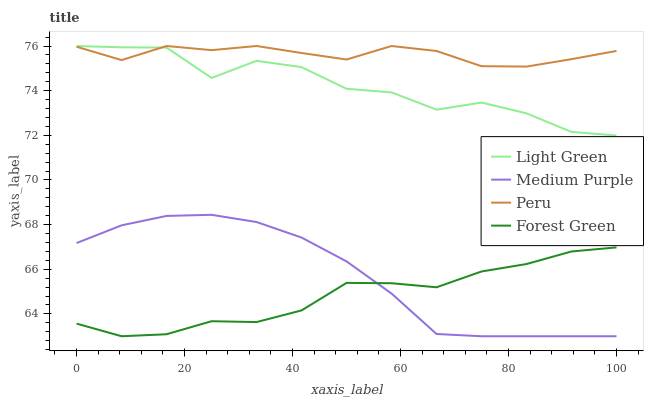Does Forest Green have the minimum area under the curve?
Answer yes or no. Yes. Does Peru have the maximum area under the curve?
Answer yes or no. Yes. Does Peru have the minimum area under the curve?
Answer yes or no. No. Does Forest Green have the maximum area under the curve?
Answer yes or no. No. Is Medium Purple the smoothest?
Answer yes or no. Yes. Is Light Green the roughest?
Answer yes or no. Yes. Is Forest Green the smoothest?
Answer yes or no. No. Is Forest Green the roughest?
Answer yes or no. No. Does Medium Purple have the lowest value?
Answer yes or no. Yes. Does Peru have the lowest value?
Answer yes or no. No. Does Light Green have the highest value?
Answer yes or no. Yes. Does Forest Green have the highest value?
Answer yes or no. No. Is Medium Purple less than Light Green?
Answer yes or no. Yes. Is Light Green greater than Forest Green?
Answer yes or no. Yes. Does Light Green intersect Peru?
Answer yes or no. Yes. Is Light Green less than Peru?
Answer yes or no. No. Is Light Green greater than Peru?
Answer yes or no. No. Does Medium Purple intersect Light Green?
Answer yes or no. No. 